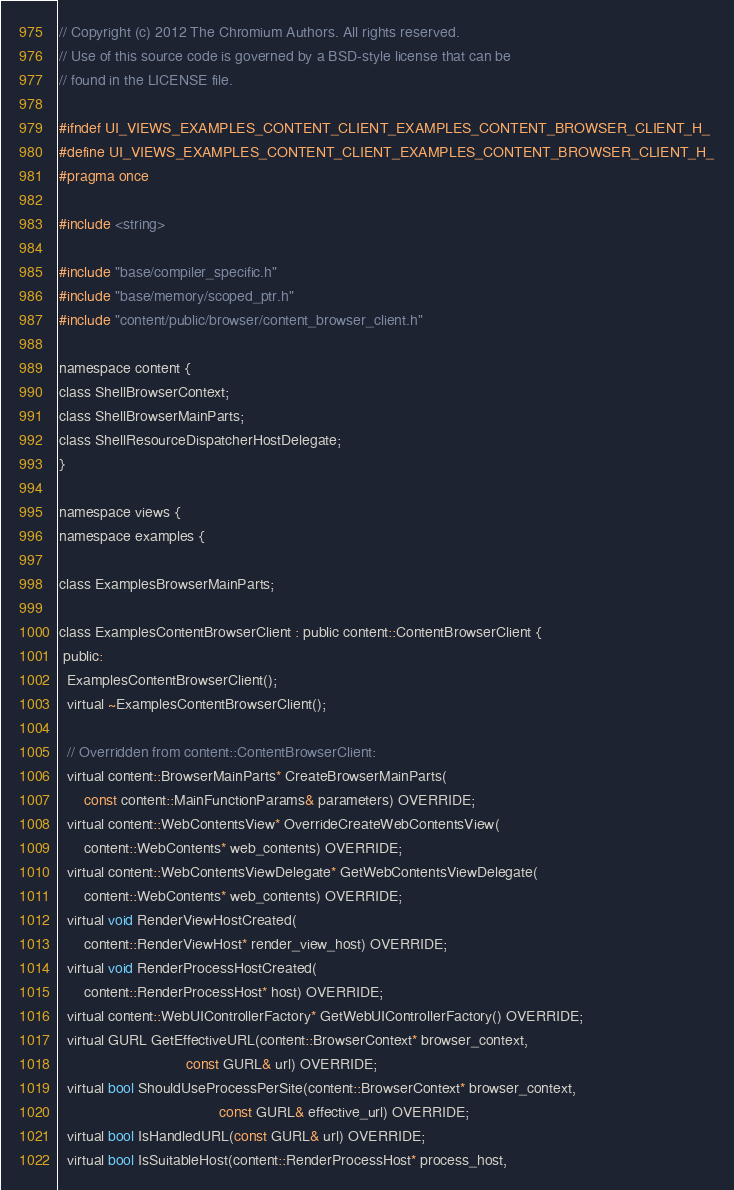<code> <loc_0><loc_0><loc_500><loc_500><_C_>// Copyright (c) 2012 The Chromium Authors. All rights reserved.
// Use of this source code is governed by a BSD-style license that can be
// found in the LICENSE file.

#ifndef UI_VIEWS_EXAMPLES_CONTENT_CLIENT_EXAMPLES_CONTENT_BROWSER_CLIENT_H_
#define UI_VIEWS_EXAMPLES_CONTENT_CLIENT_EXAMPLES_CONTENT_BROWSER_CLIENT_H_
#pragma once

#include <string>

#include "base/compiler_specific.h"
#include "base/memory/scoped_ptr.h"
#include "content/public/browser/content_browser_client.h"

namespace content {
class ShellBrowserContext;
class ShellBrowserMainParts;
class ShellResourceDispatcherHostDelegate;
}

namespace views {
namespace examples {

class ExamplesBrowserMainParts;

class ExamplesContentBrowserClient : public content::ContentBrowserClient {
 public:
  ExamplesContentBrowserClient();
  virtual ~ExamplesContentBrowserClient();

  // Overridden from content::ContentBrowserClient:
  virtual content::BrowserMainParts* CreateBrowserMainParts(
      const content::MainFunctionParams& parameters) OVERRIDE;
  virtual content::WebContentsView* OverrideCreateWebContentsView(
      content::WebContents* web_contents) OVERRIDE;
  virtual content::WebContentsViewDelegate* GetWebContentsViewDelegate(
      content::WebContents* web_contents) OVERRIDE;
  virtual void RenderViewHostCreated(
      content::RenderViewHost* render_view_host) OVERRIDE;
  virtual void RenderProcessHostCreated(
      content::RenderProcessHost* host) OVERRIDE;
  virtual content::WebUIControllerFactory* GetWebUIControllerFactory() OVERRIDE;
  virtual GURL GetEffectiveURL(content::BrowserContext* browser_context,
                               const GURL& url) OVERRIDE;
  virtual bool ShouldUseProcessPerSite(content::BrowserContext* browser_context,
                                       const GURL& effective_url) OVERRIDE;
  virtual bool IsHandledURL(const GURL& url) OVERRIDE;
  virtual bool IsSuitableHost(content::RenderProcessHost* process_host,</code> 